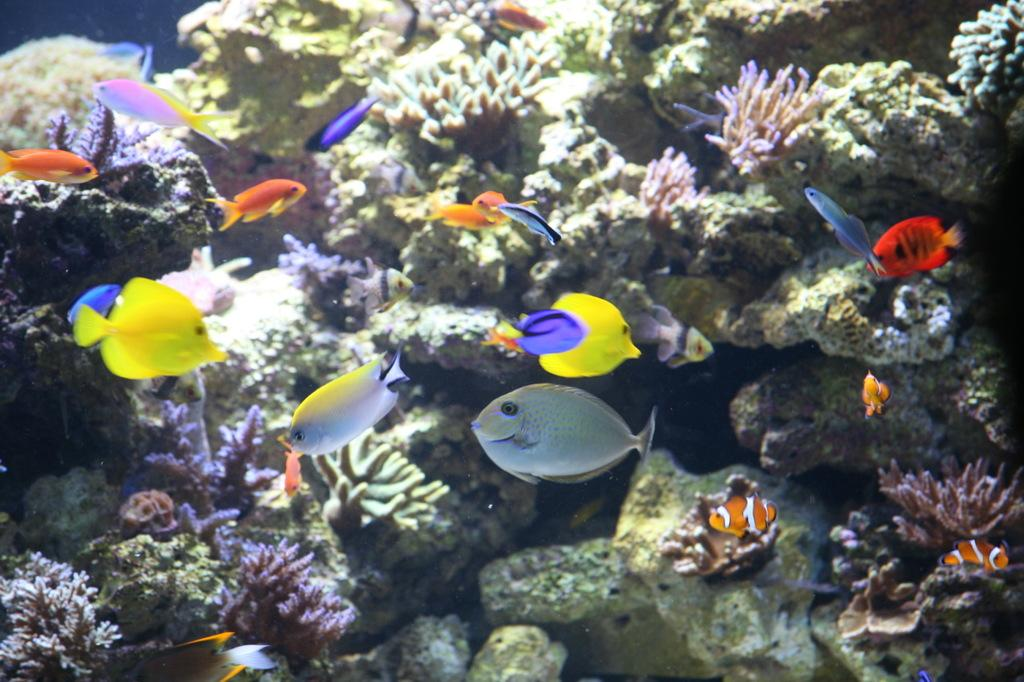What type of animals can be seen in the image? There are fishes in the water in the image. What other objects or features can be seen in the image? There are stones and a coral reef visible in the image. What type of sheet is covering the sun in the image? There is no sheet covering the sun in the image, as it is an underwater scene with no visible sun. 